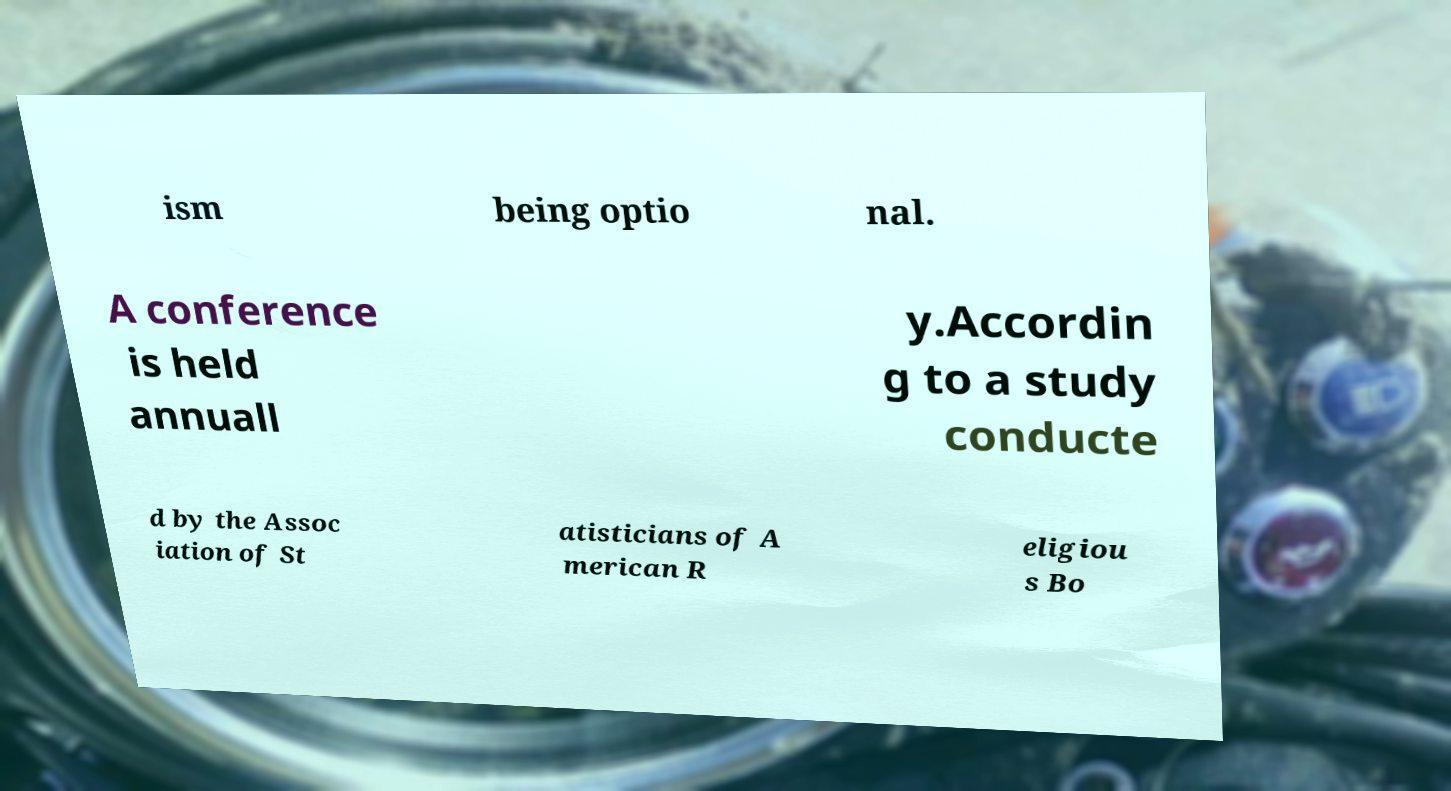I need the written content from this picture converted into text. Can you do that? ism being optio nal. A conference is held annuall y.Accordin g to a study conducte d by the Assoc iation of St atisticians of A merican R eligiou s Bo 